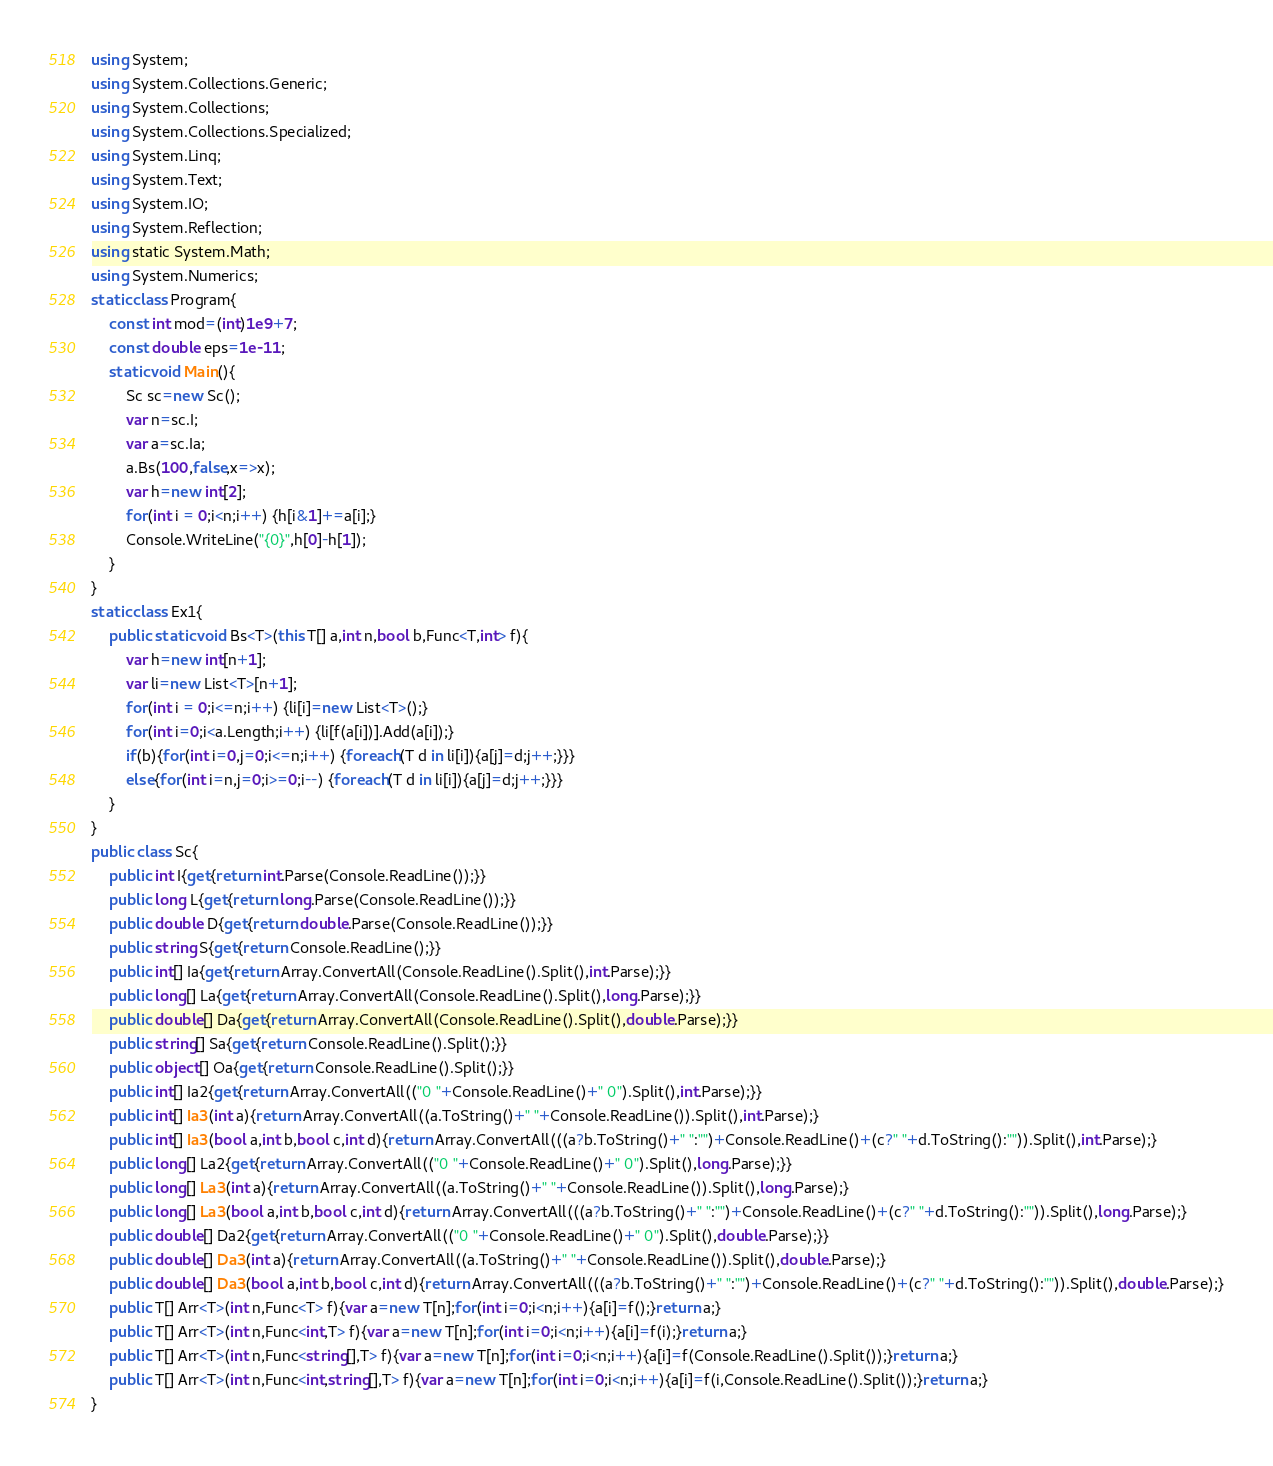Convert code to text. <code><loc_0><loc_0><loc_500><loc_500><_C#_>using System;
using System.Collections.Generic;
using System.Collections;
using System.Collections.Specialized;
using System.Linq;
using System.Text;
using System.IO;
using System.Reflection;
using static System.Math;
using System.Numerics;
static class Program{
	const int mod=(int)1e9+7;
	const double eps=1e-11;
	static void Main(){
		Sc sc=new Sc();
		var n=sc.I;
		var a=sc.Ia;
		a.Bs(100,false,x=>x);
		var h=new int[2];
		for(int i = 0;i<n;i++) {h[i&1]+=a[i];}
		Console.WriteLine("{0}",h[0]-h[1]);
	}
}
static class Ex1{
	public static void Bs<T>(this T[] a,int n,bool b,Func<T,int> f){
		var h=new int[n+1];
		var li=new List<T>[n+1];
		for(int i = 0;i<=n;i++) {li[i]=new List<T>();}
		for(int i=0;i<a.Length;i++) {li[f(a[i])].Add(a[i]);}
		if(b){for(int i=0,j=0;i<=n;i++) {foreach(T d in li[i]){a[j]=d;j++;}}}
		else{for(int i=n,j=0;i>=0;i--) {foreach(T d in li[i]){a[j]=d;j++;}}}
	}
}
public class Sc{
	public int I{get{return int.Parse(Console.ReadLine());}}
	public long L{get{return long.Parse(Console.ReadLine());}}
	public double D{get{return double.Parse(Console.ReadLine());}}
	public string S{get{return Console.ReadLine();}}
	public int[] Ia{get{return Array.ConvertAll(Console.ReadLine().Split(),int.Parse);}}
	public long[] La{get{return Array.ConvertAll(Console.ReadLine().Split(),long.Parse);}}
	public double[] Da{get{return Array.ConvertAll(Console.ReadLine().Split(),double.Parse);}}
	public string[] Sa{get{return Console.ReadLine().Split();}}
	public object[] Oa{get{return Console.ReadLine().Split();}}
	public int[] Ia2{get{return Array.ConvertAll(("0 "+Console.ReadLine()+" 0").Split(),int.Parse);}}
	public int[] Ia3(int a){return Array.ConvertAll((a.ToString()+" "+Console.ReadLine()).Split(),int.Parse);}
	public int[] Ia3(bool a,int b,bool c,int d){return Array.ConvertAll(((a?b.ToString()+" ":"")+Console.ReadLine()+(c?" "+d.ToString():"")).Split(),int.Parse);}
	public long[] La2{get{return Array.ConvertAll(("0 "+Console.ReadLine()+" 0").Split(),long.Parse);}}
	public long[] La3(int a){return Array.ConvertAll((a.ToString()+" "+Console.ReadLine()).Split(),long.Parse);}
	public long[] La3(bool a,int b,bool c,int d){return Array.ConvertAll(((a?b.ToString()+" ":"")+Console.ReadLine()+(c?" "+d.ToString():"")).Split(),long.Parse);}
	public double[] Da2{get{return Array.ConvertAll(("0 "+Console.ReadLine()+" 0").Split(),double.Parse);}}
	public double[] Da3(int a){return Array.ConvertAll((a.ToString()+" "+Console.ReadLine()).Split(),double.Parse);}
	public double[] Da3(bool a,int b,bool c,int d){return Array.ConvertAll(((a?b.ToString()+" ":"")+Console.ReadLine()+(c?" "+d.ToString():"")).Split(),double.Parse);}
	public T[] Arr<T>(int n,Func<T> f){var a=new T[n];for(int i=0;i<n;i++){a[i]=f();}return a;}
	public T[] Arr<T>(int n,Func<int,T> f){var a=new T[n];for(int i=0;i<n;i++){a[i]=f(i);}return a;}
	public T[] Arr<T>(int n,Func<string[],T> f){var a=new T[n];for(int i=0;i<n;i++){a[i]=f(Console.ReadLine().Split());}return a;}
	public T[] Arr<T>(int n,Func<int,string[],T> f){var a=new T[n];for(int i=0;i<n;i++){a[i]=f(i,Console.ReadLine().Split());}return a;}
}</code> 